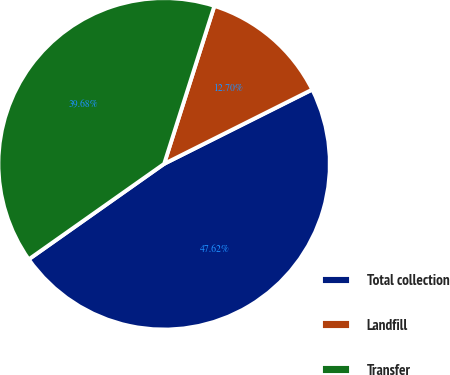Convert chart. <chart><loc_0><loc_0><loc_500><loc_500><pie_chart><fcel>Total collection<fcel>Landfill<fcel>Transfer<nl><fcel>47.62%<fcel>12.7%<fcel>39.68%<nl></chart> 